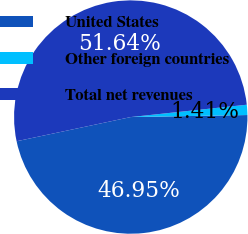<chart> <loc_0><loc_0><loc_500><loc_500><pie_chart><fcel>United States<fcel>Other foreign countries<fcel>Total net revenues<nl><fcel>46.95%<fcel>1.41%<fcel>51.64%<nl></chart> 